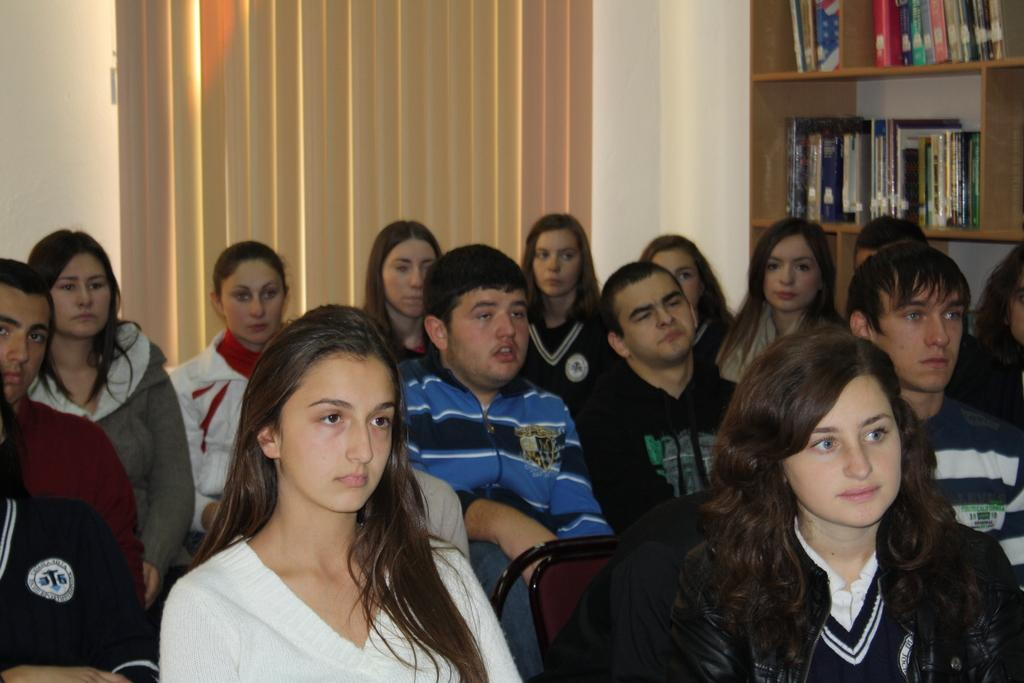What are the people in the foreground of the image doing? The persons sitting on chairs in the foreground of the image are likely resting or engaged in a conversation. What can be seen in the background of the image? In the background of the image, there is a rack with books and a window blind. There is also a wall visible. Can you describe the books on the rack? Unfortunately, the facts provided do not give any information about the books on the rack, so we cannot describe them. How many ants are crawling on the persons sitting on chairs in the image? There are no ants visible in the image; the persons are sitting on chairs without any insects present. 